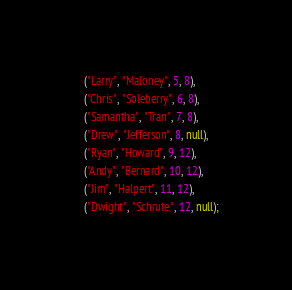<code> <loc_0><loc_0><loc_500><loc_500><_SQL_>    ("Larry", "Maloney", 5, 8), 
    ("Chris", "Soleberry", 6, 8), 
    ("Samantha", "Tran", 7, 8), 
    ("Drew", "Jefferson", 8, null), 
    ("Ryan", "Howard", 9, 12), 
    ("Andy", "Bernard", 10, 12), 
    ("Jim", "Halpert", 11, 12), 
    ("Dwight", "Schrute", 12, null);
</code> 